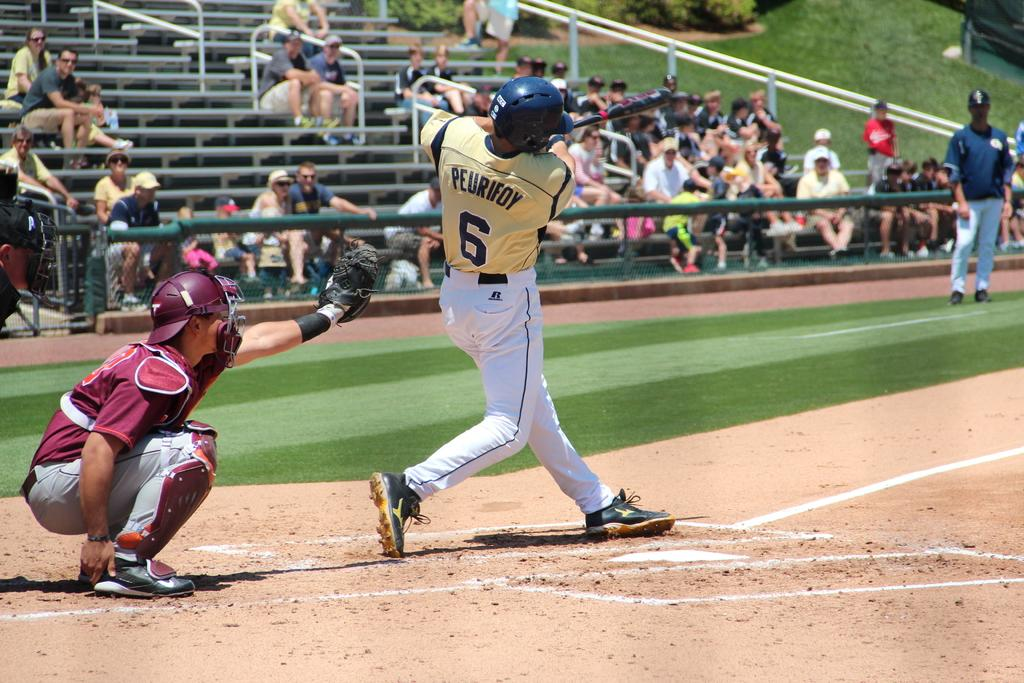<image>
Present a compact description of the photo's key features. The baseball player at bat is number 6 